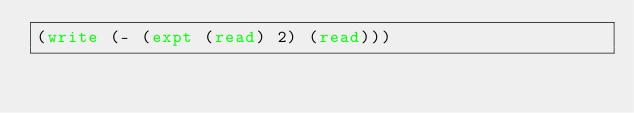Convert code to text. <code><loc_0><loc_0><loc_500><loc_500><_Lisp_>(write (- (expt (read) 2) (read)))
</code> 